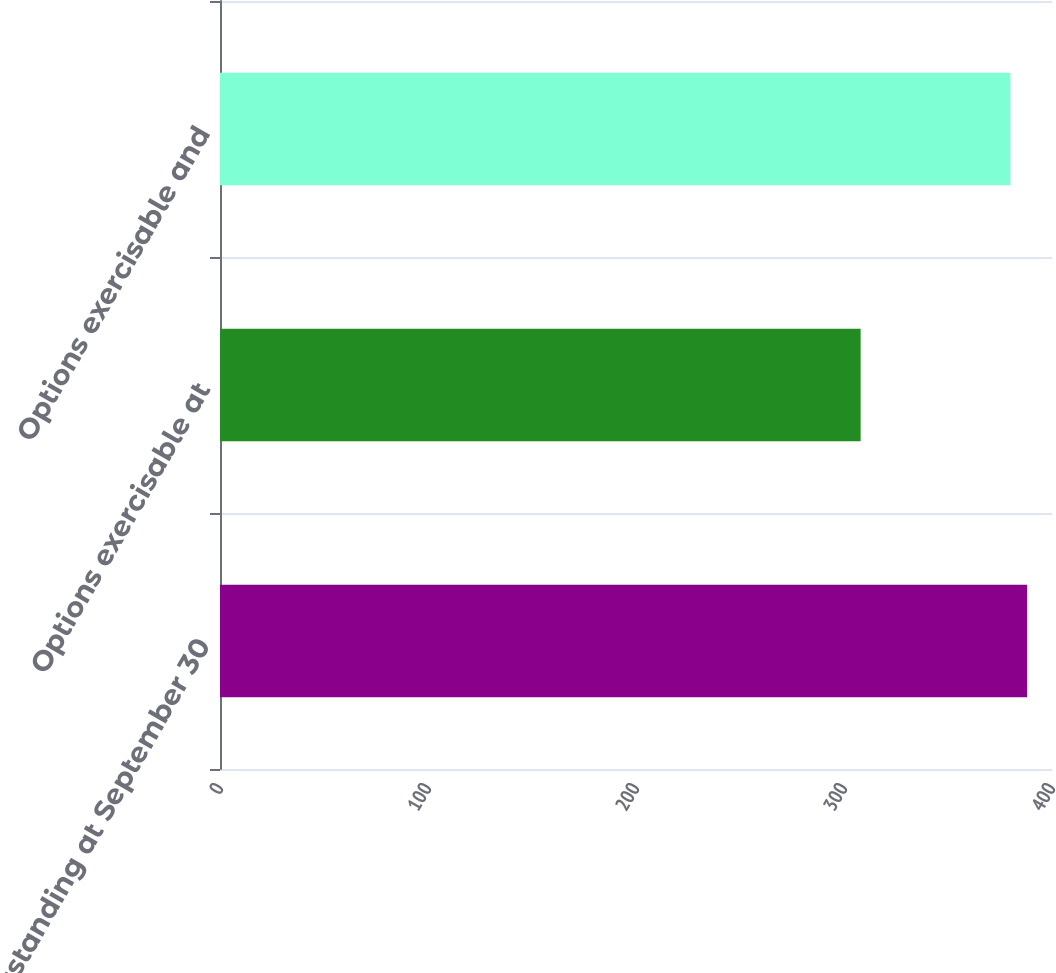Convert chart to OTSL. <chart><loc_0><loc_0><loc_500><loc_500><bar_chart><fcel>Outstanding at September 30<fcel>Options exercisable at<fcel>Options exercisable and<nl><fcel>388<fcel>308<fcel>380<nl></chart> 